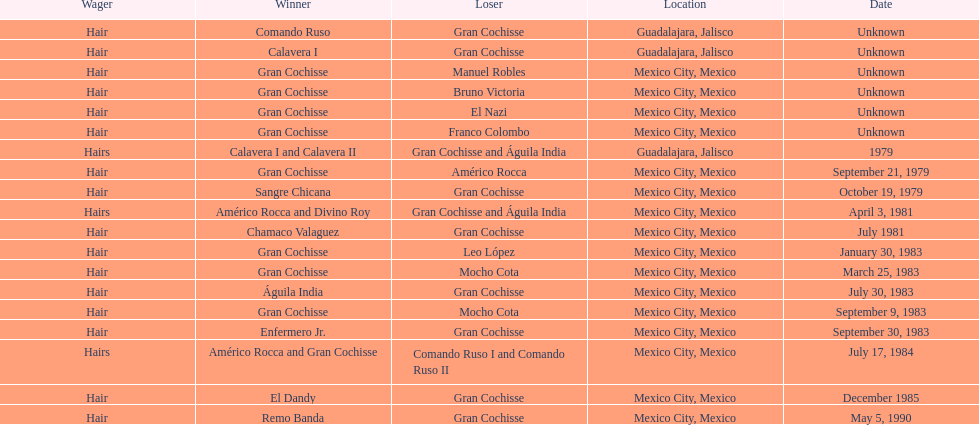How many times has the wager been hair? 16. 